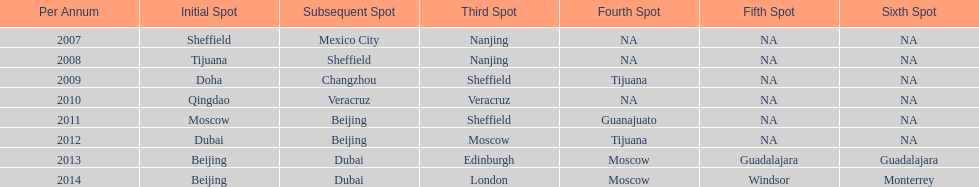What was the last year where tijuana was a venue? 2012. 